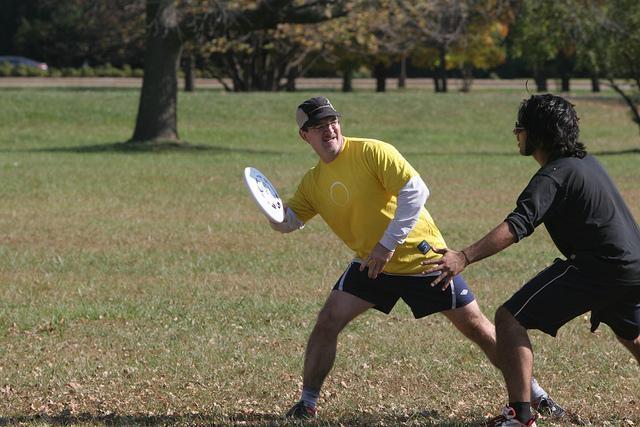How many people can you see?
Give a very brief answer. 2. 